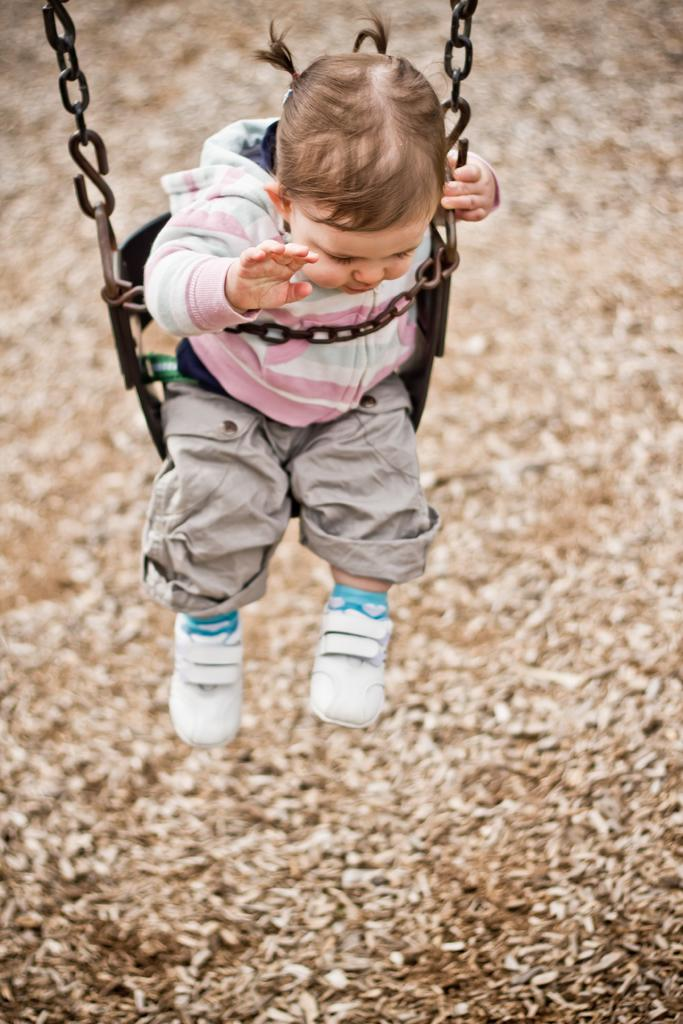What is the main subject of the image? There is a kid in a swing in the image. What can be seen at the bottom of the image? Dry leaves are present at the bottom of the image. How would you describe the background of the image? The background of the image is blurred. What type of war is depicted in the image? There is no war depicted in the image; it features a kid in a swing with dry leaves at the bottom and a blurred background. How many celery stalks can be seen in the image? There is no celery present in the image. 